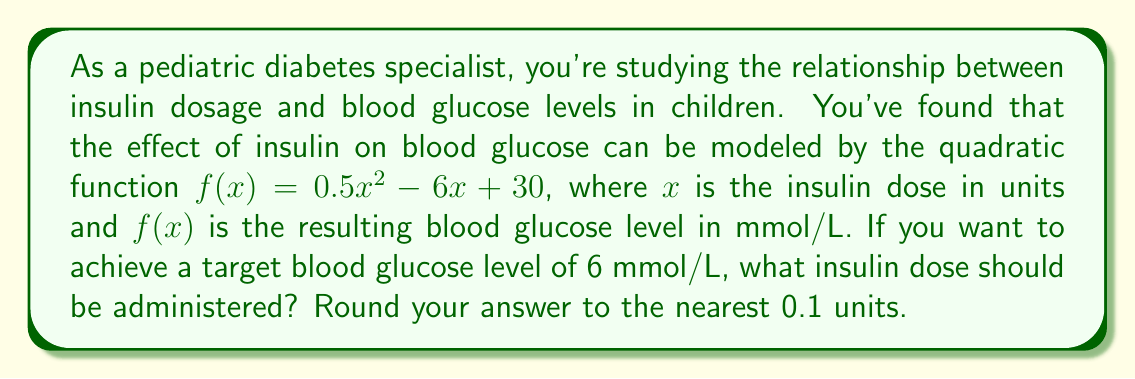Show me your answer to this math problem. To solve this problem, we need to find the value of $x$ that makes $f(x) = 6$. This involves the following steps:

1) Set up the equation:
   $0.5x^2 - 6x + 30 = 6$

2) Rearrange to standard form:
   $0.5x^2 - 6x + 24 = 0$

3) This is a quadratic equation. We can solve it using the quadratic formula:
   $x = \frac{-b \pm \sqrt{b^2 - 4ac}}{2a}$

   Where $a = 0.5$, $b = -6$, and $c = 24$

4) Substitute these values into the quadratic formula:
   $x = \frac{6 \pm \sqrt{(-6)^2 - 4(0.5)(24)}}{2(0.5)}$

5) Simplify:
   $x = \frac{6 \pm \sqrt{36 - 48}}{1} = \frac{6 \pm \sqrt{-12}}{1}$

6) Simplify further:
   $x = 6 \pm 2\sqrt{3}i$

7) Since we're dealing with real-world insulin doses, we can discard the imaginary solution. Our solution is:
   $x = 6 + 2\sqrt{3} \approx 9.46$

8) Rounding to the nearest 0.1 units:
   $x \approx 9.5$
Answer: The insulin dose should be approximately 9.5 units. 